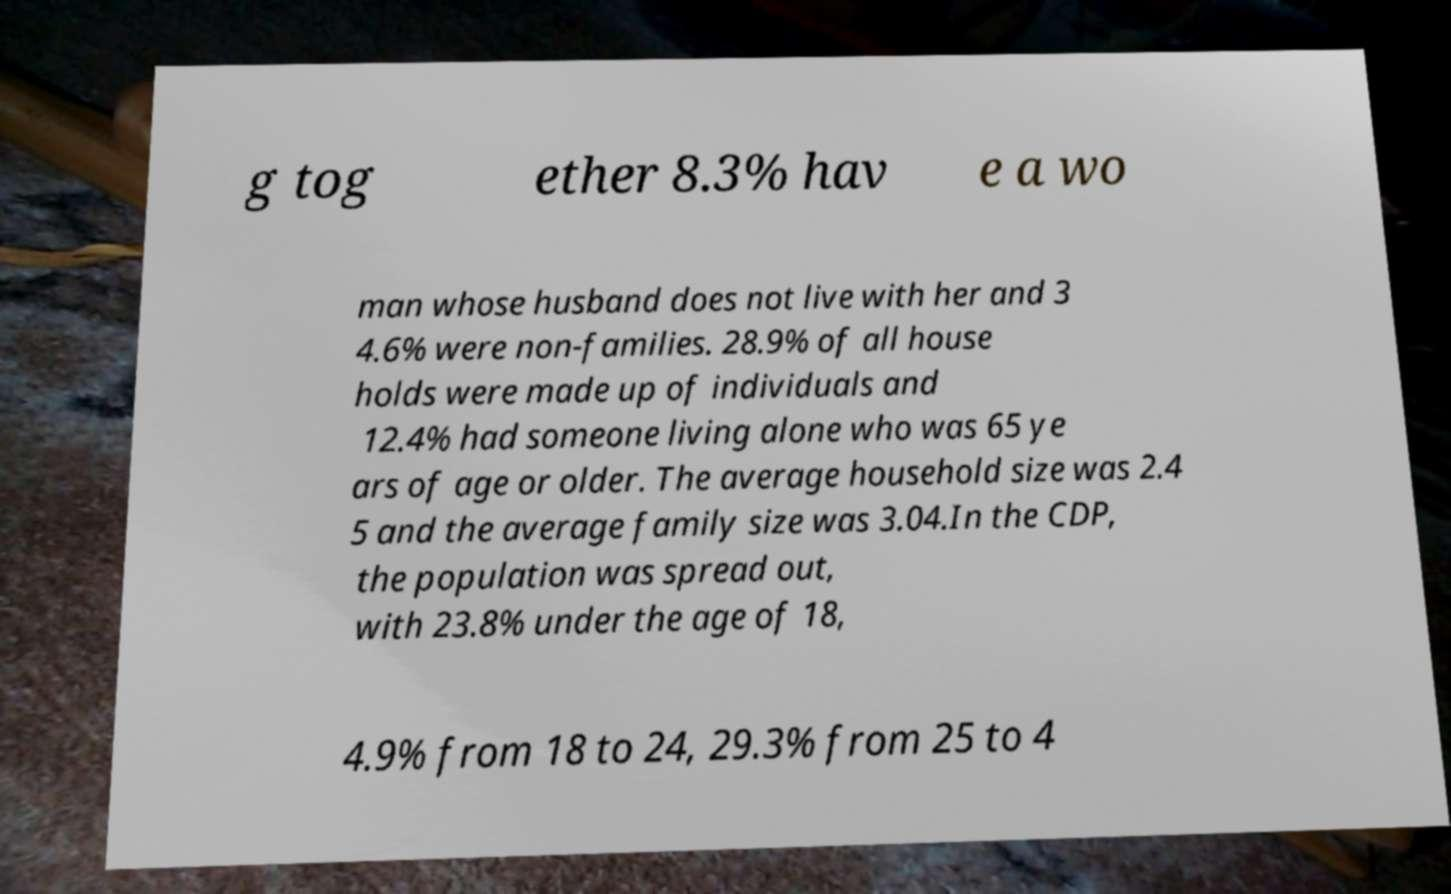Please identify and transcribe the text found in this image. g tog ether 8.3% hav e a wo man whose husband does not live with her and 3 4.6% were non-families. 28.9% of all house holds were made up of individuals and 12.4% had someone living alone who was 65 ye ars of age or older. The average household size was 2.4 5 and the average family size was 3.04.In the CDP, the population was spread out, with 23.8% under the age of 18, 4.9% from 18 to 24, 29.3% from 25 to 4 